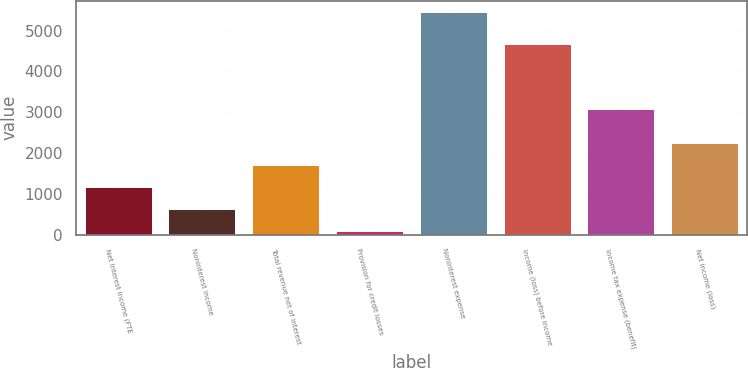Convert chart to OTSL. <chart><loc_0><loc_0><loc_500><loc_500><bar_chart><fcel>Net interest income (FTE<fcel>Noninterest income<fcel>Total revenue net of interest<fcel>Provision for credit losses<fcel>Noninterest expense<fcel>Income (loss) before income<fcel>Income tax expense (benefit)<fcel>Net income (loss)<nl><fcel>1172<fcel>636<fcel>1708<fcel>100<fcel>5460<fcel>4660<fcel>3085<fcel>2244<nl></chart> 